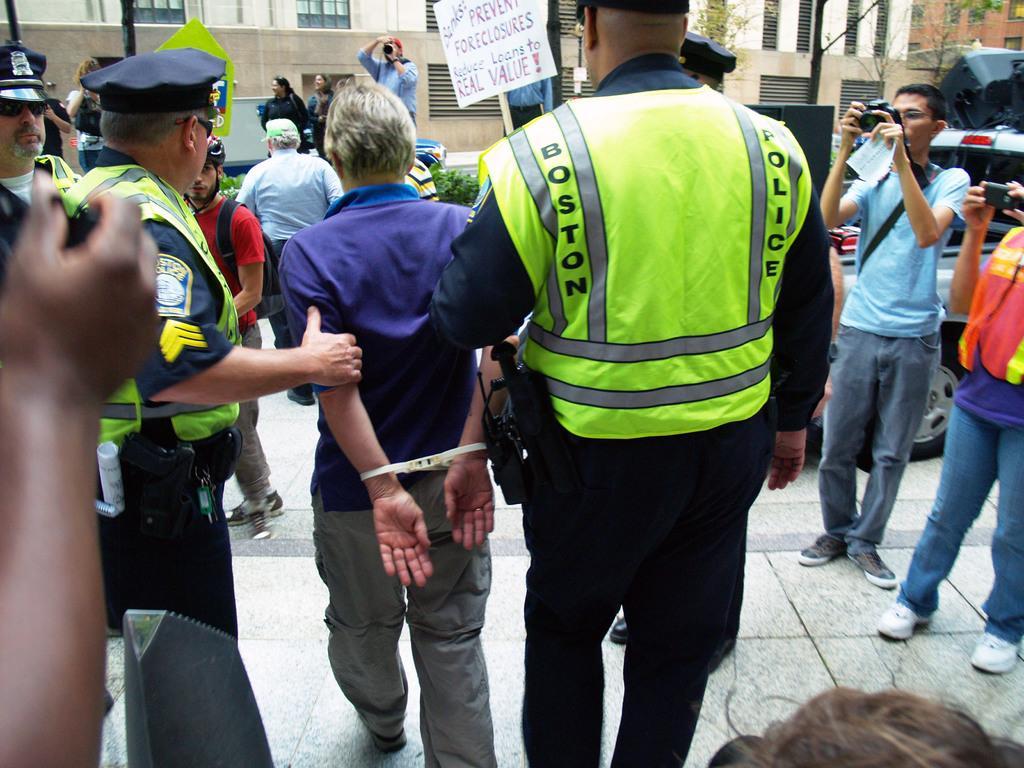Could you give a brief overview of what you see in this image? In this image we can see some people, some vehicles, some objects are on the surface, some buildings, some poles, some trees, one white board with text attached to the pole, some people are standing and taking photos and some people holding some objects. Time police officers are arrested one man and walking. 